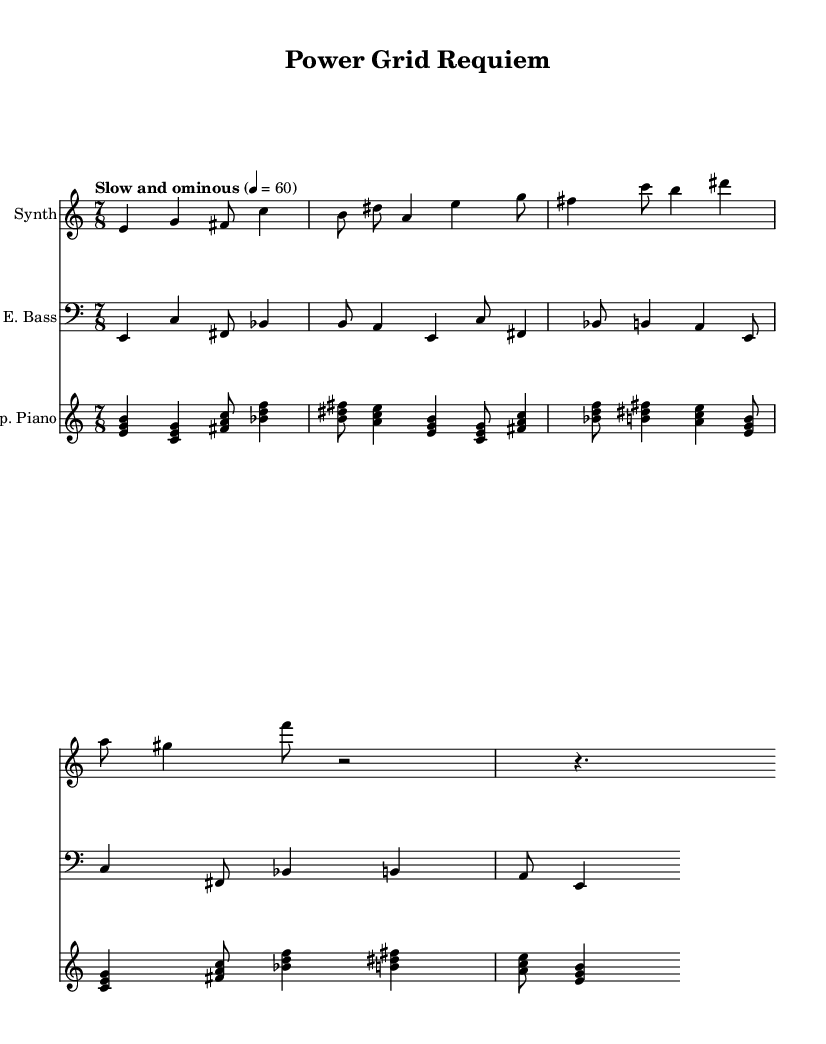What is the time signature of this music? The time signature is shown at the beginning of the music sheet as 7/8, indicating that there are seven beats in each measure and the eighth note gets the beat.
Answer: 7/8 What is the tempo marking for this piece? The tempo marking in the music is indicated as "Slow and ominous" with a metronome marking of 4 = 60, meaning that the quarter note should be played at a speed of 60 beats per minute.
Answer: Slow and ominous What clef is used for the synthesizer part? The clef for the synthesizer part is a treble clef, which is typically used for higher-pitched instruments and voices.
Answer: Treble How many measures are in the synthesizer part? By counting the individual measures in the synthesizer section, there are four measures present, marked by the appearance of vertical lines separating groups of notes.
Answer: 4 What is the primary instrument in the prepared piano part? The prepared piano part features unique note clusters and alterations typical of a prepared piano, where objects are placed on or between the strings to create different sound effects.
Answer: Prepared piano Which chords are used in the prepared piano section? The prepared piano section includes various clustered chords, including e minor, c major, and f sharp major, all represented by the notes within the brackets.
Answer: e minor, c major, f sharp major In which staff is the electric bass written? The electric bass is notated in the bass clef staff, which is specifically designed for lower-pitched instruments.
Answer: Bass clef 